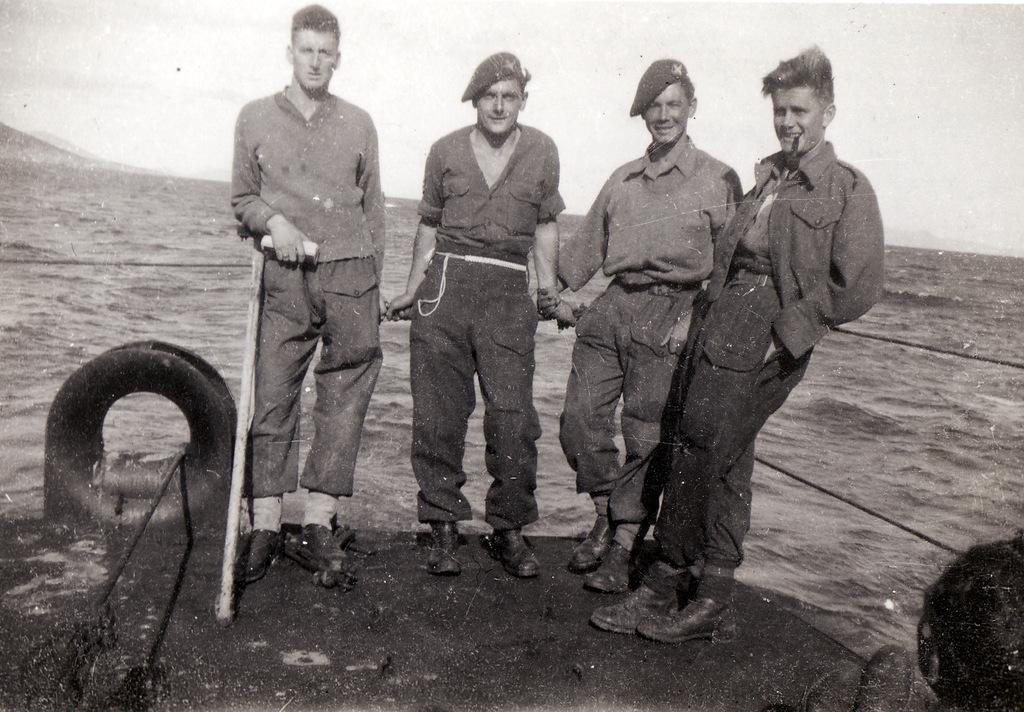How many people are present in the image? There are four people standing in the image. What is the facial expression of the people in the image? The people are smiling. What objects can be seen in the image besides the people? There are ropes, a stick, and a tire visible in the image. What can be seen in the background of the image? The background of the image includes the sea. What type of art is the head of the achiever displayed in the image? There is no head or achiever present in the image, and therefore no such art can be observed. 